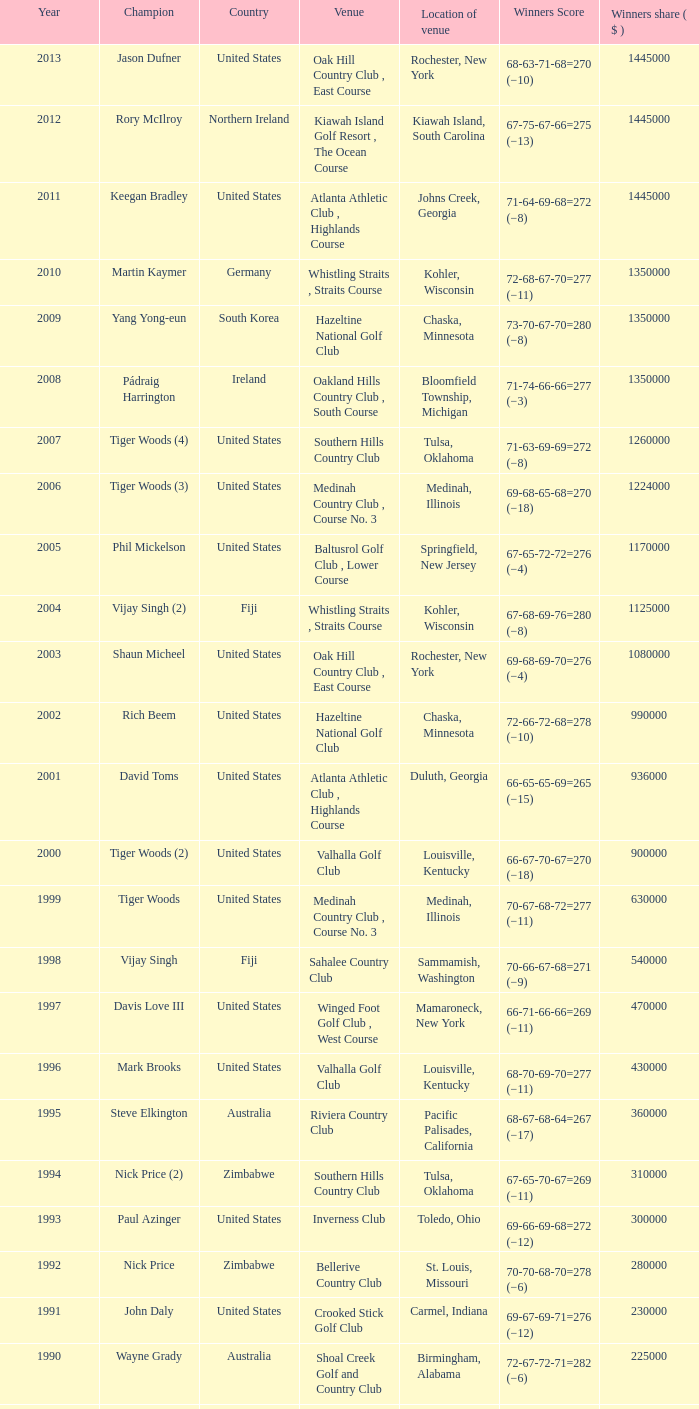Enumerate all victorious scores from 1982. 63-69-68-72=272 (−8). 